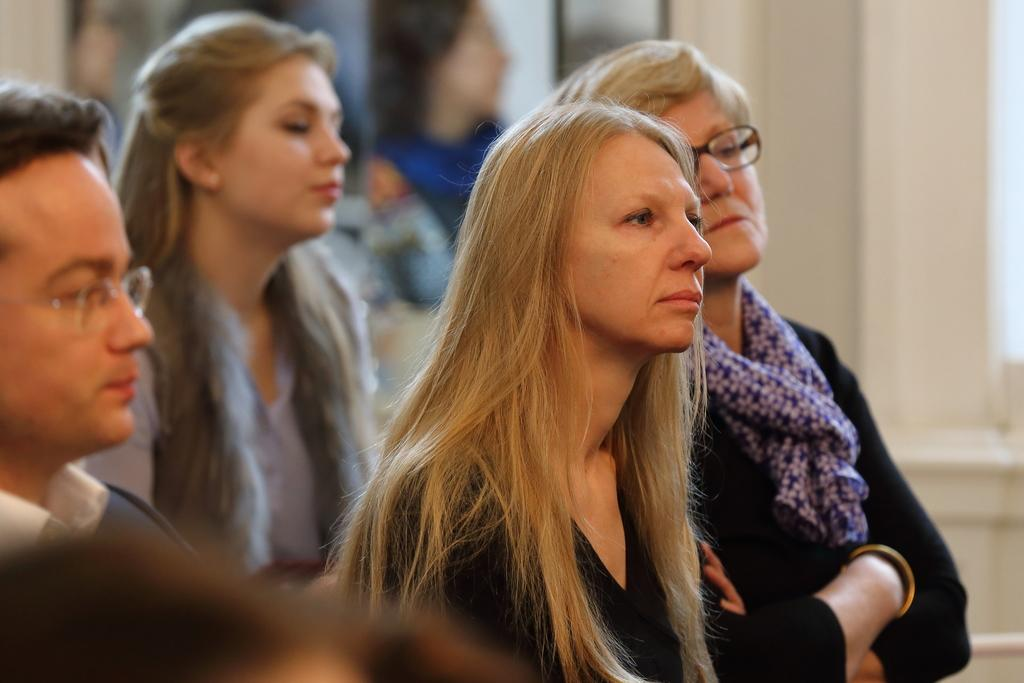How many people are in the image? There are three women and a man standing in the image, making a total of four people. What can be seen in the image besides the people? There appears to be a pillar in the image. Can you describe the background of the image? The background of the image is blurry. What type of locket is the man holding in the image? There is no locket present in the image; the man is not holding any object. How many crates are visible in the image? There are no crates present in the image. 